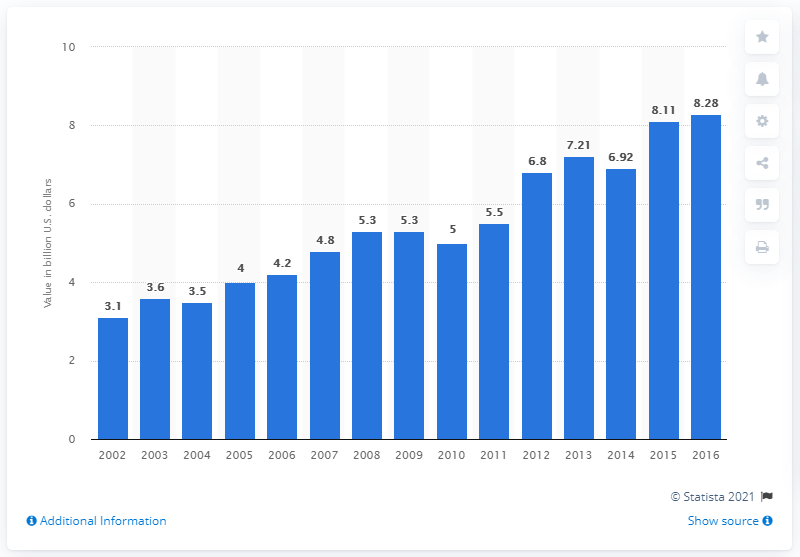Mention a couple of crucial points in this snapshot. In 2016, the value of bottled liquor in the United States was approximately 8.28 billion dollars. 